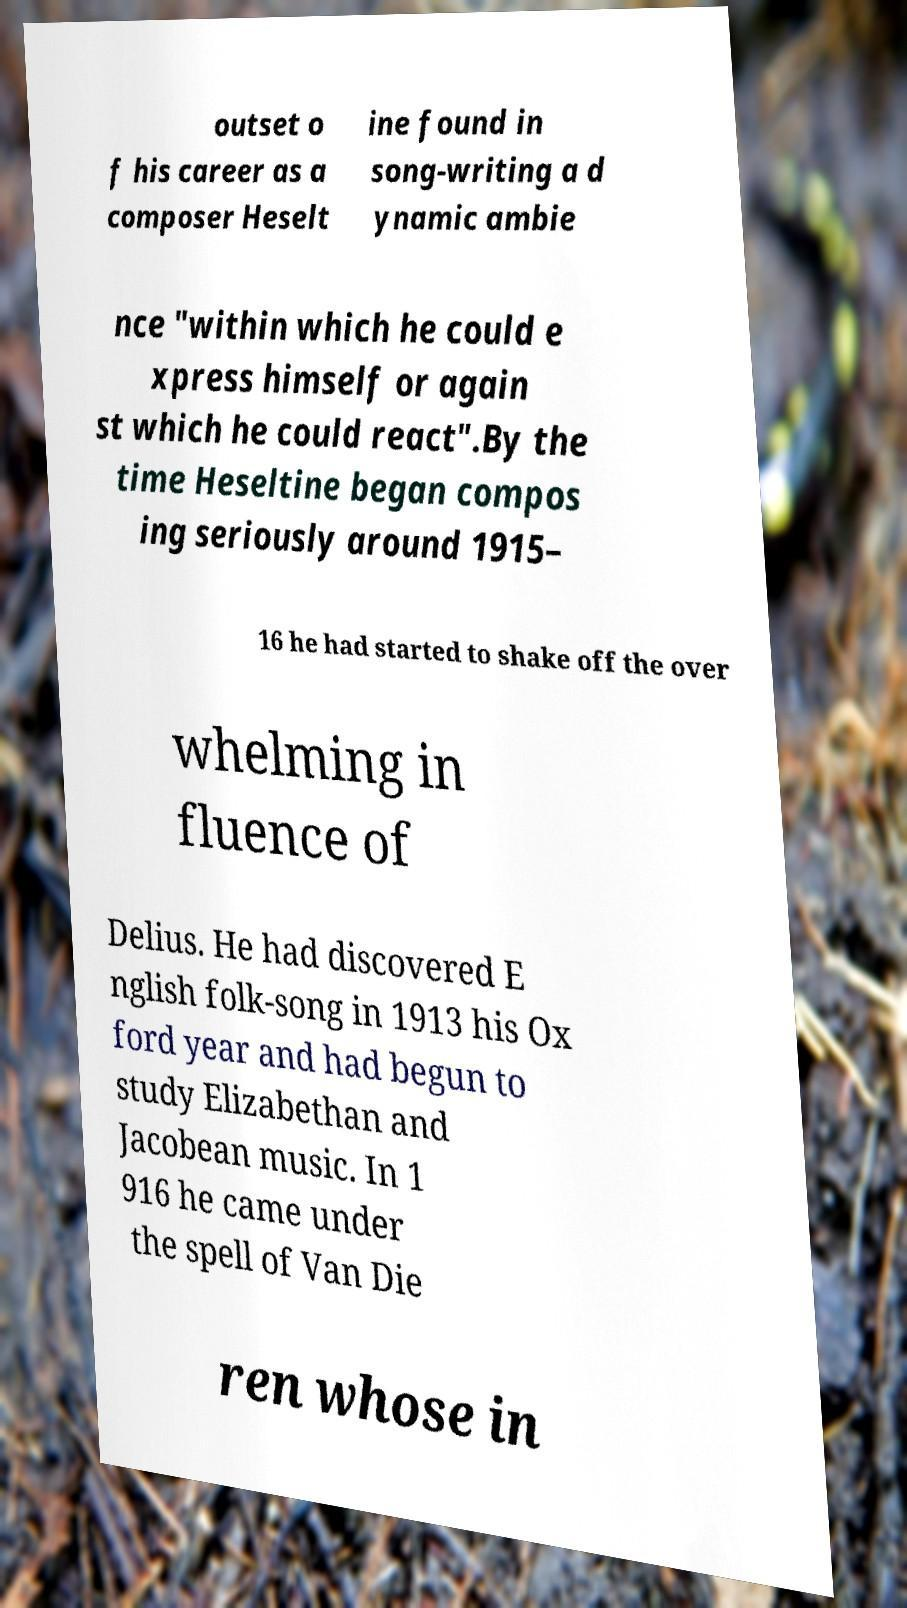Can you accurately transcribe the text from the provided image for me? outset o f his career as a composer Heselt ine found in song-writing a d ynamic ambie nce "within which he could e xpress himself or again st which he could react".By the time Heseltine began compos ing seriously around 1915– 16 he had started to shake off the over whelming in fluence of Delius. He had discovered E nglish folk-song in 1913 his Ox ford year and had begun to study Elizabethan and Jacobean music. In 1 916 he came under the spell of Van Die ren whose in 